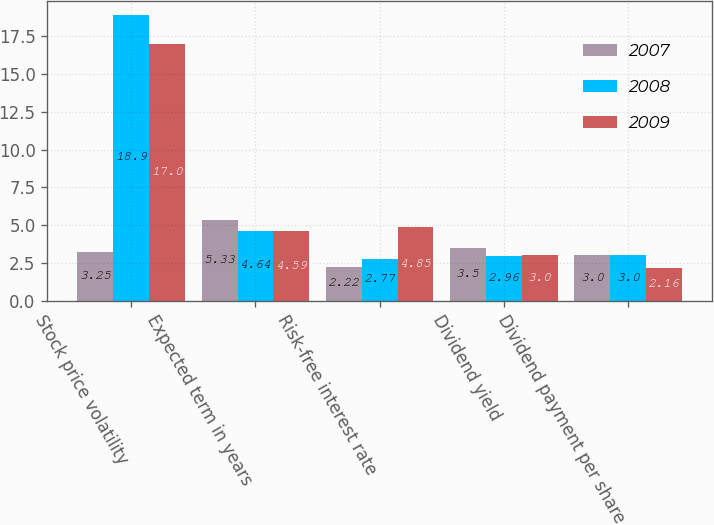Convert chart. <chart><loc_0><loc_0><loc_500><loc_500><stacked_bar_chart><ecel><fcel>Stock price volatility<fcel>Expected term in years<fcel>Risk-free interest rate<fcel>Dividend yield<fcel>Dividend payment per share<nl><fcel>2007<fcel>3.25<fcel>5.33<fcel>2.22<fcel>3.5<fcel>3<nl><fcel>2008<fcel>18.9<fcel>4.64<fcel>2.77<fcel>2.96<fcel>3<nl><fcel>2009<fcel>17<fcel>4.59<fcel>4.85<fcel>3<fcel>2.16<nl></chart> 